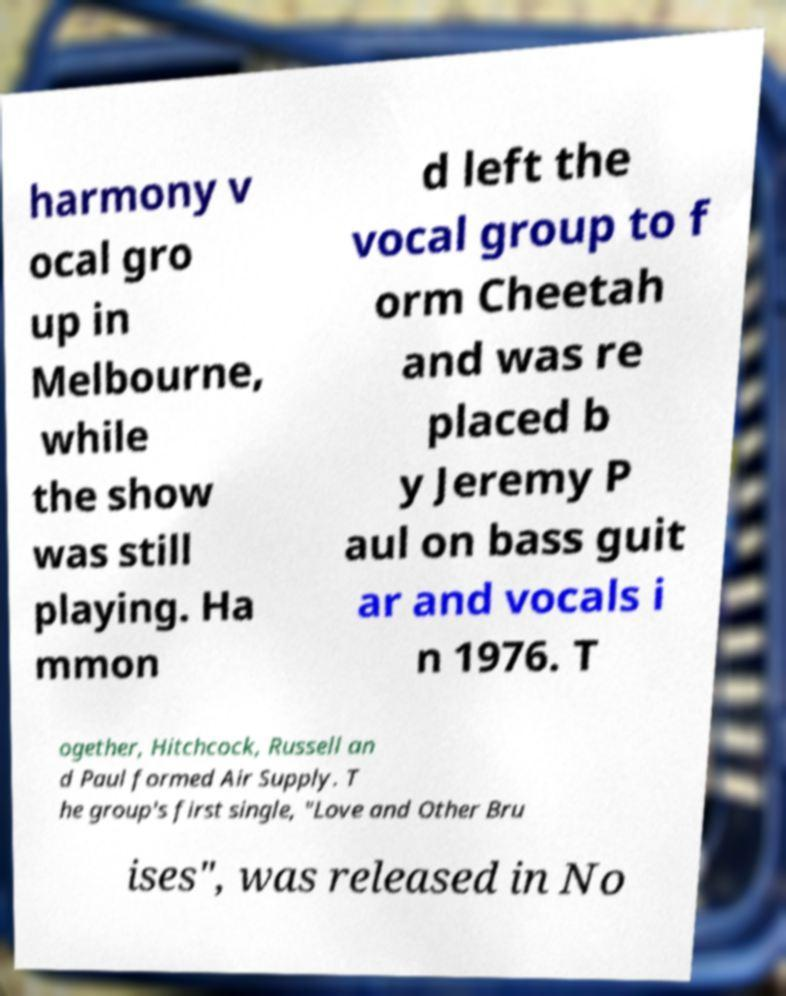There's text embedded in this image that I need extracted. Can you transcribe it verbatim? harmony v ocal gro up in Melbourne, while the show was still playing. Ha mmon d left the vocal group to f orm Cheetah and was re placed b y Jeremy P aul on bass guit ar and vocals i n 1976. T ogether, Hitchcock, Russell an d Paul formed Air Supply. T he group's first single, "Love and Other Bru ises", was released in No 